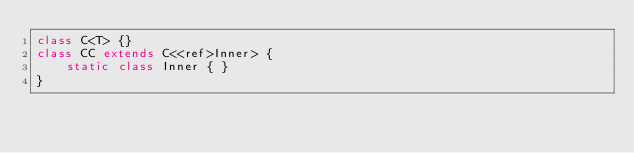Convert code to text. <code><loc_0><loc_0><loc_500><loc_500><_Java_>class C<T> {}
class CC extends C<<ref>Inner> {
    static class Inner { }
}</code> 